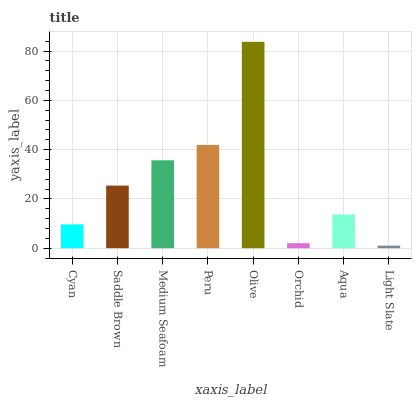Is Light Slate the minimum?
Answer yes or no. Yes. Is Olive the maximum?
Answer yes or no. Yes. Is Saddle Brown the minimum?
Answer yes or no. No. Is Saddle Brown the maximum?
Answer yes or no. No. Is Saddle Brown greater than Cyan?
Answer yes or no. Yes. Is Cyan less than Saddle Brown?
Answer yes or no. Yes. Is Cyan greater than Saddle Brown?
Answer yes or no. No. Is Saddle Brown less than Cyan?
Answer yes or no. No. Is Saddle Brown the high median?
Answer yes or no. Yes. Is Aqua the low median?
Answer yes or no. Yes. Is Cyan the high median?
Answer yes or no. No. Is Light Slate the low median?
Answer yes or no. No. 